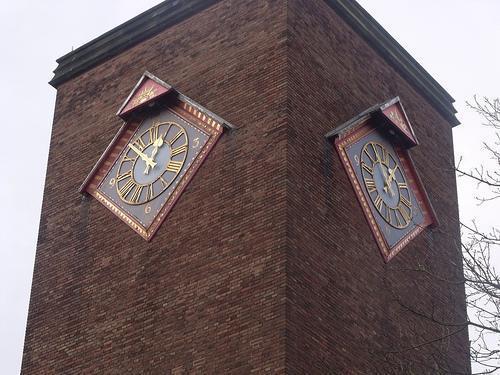How many clocks are in the picture?
Give a very brief answer. 2. 